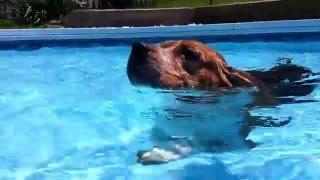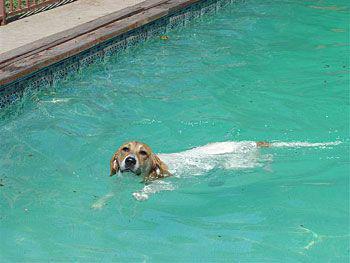The first image is the image on the left, the second image is the image on the right. Evaluate the accuracy of this statement regarding the images: "There are two beagles swimming and both of them have their heads above water.". Is it true? Answer yes or no. Yes. The first image is the image on the left, the second image is the image on the right. Analyze the images presented: Is the assertion "Dogs are swimming in an outdoor swimming pool." valid? Answer yes or no. Yes. 